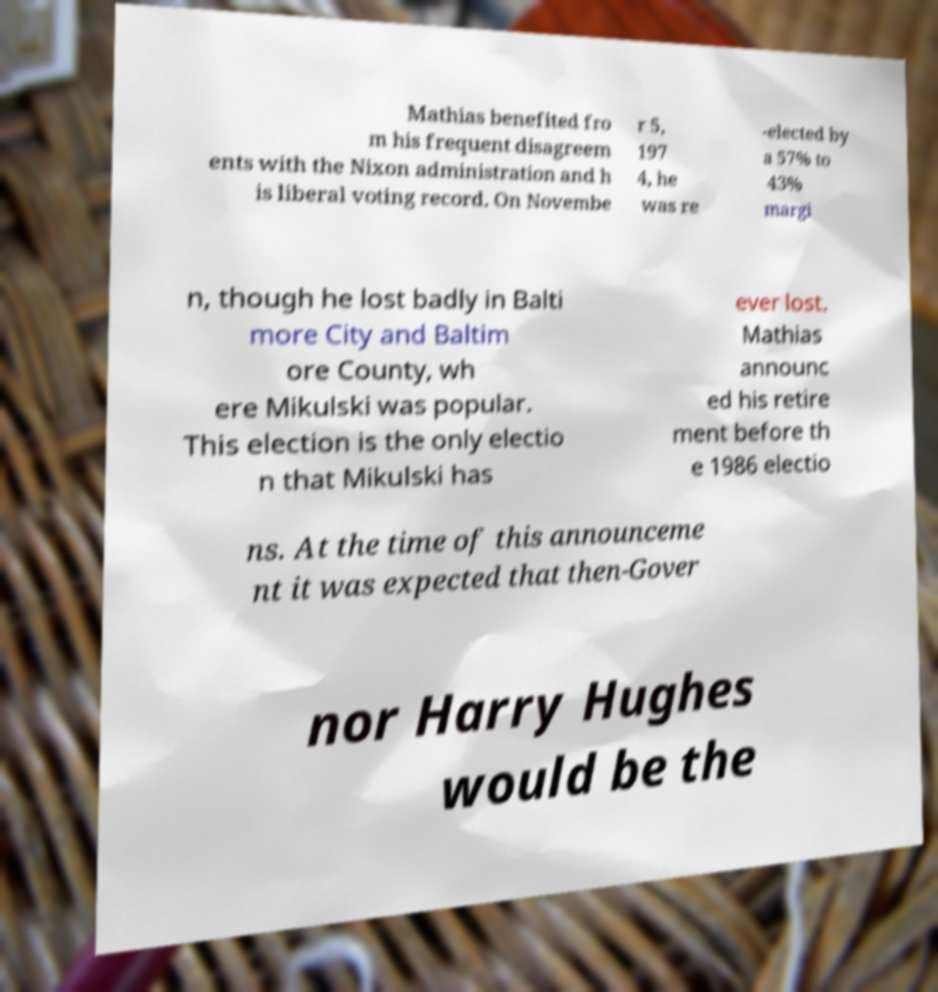Please identify and transcribe the text found in this image. Mathias benefited fro m his frequent disagreem ents with the Nixon administration and h is liberal voting record. On Novembe r 5, 197 4, he was re -elected by a 57% to 43% margi n, though he lost badly in Balti more City and Baltim ore County, wh ere Mikulski was popular. This election is the only electio n that Mikulski has ever lost. Mathias announc ed his retire ment before th e 1986 electio ns. At the time of this announceme nt it was expected that then-Gover nor Harry Hughes would be the 